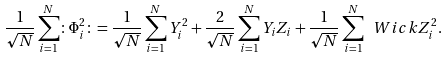<formula> <loc_0><loc_0><loc_500><loc_500>\frac { 1 } { \sqrt { N } } \sum _ { i = 1 } ^ { N } \colon \Phi _ { i } ^ { 2 } \colon = \frac { 1 } { \sqrt { N } } \sum _ { i = 1 } ^ { N } Y _ { i } ^ { 2 } + \frac { 2 } { \sqrt { N } } \sum _ { i = 1 } ^ { N } Y _ { i } Z _ { i } + \frac { 1 } { \sqrt { N } } \sum _ { i = 1 } ^ { N } \ W i c k { Z _ { i } ^ { 2 } } .</formula> 